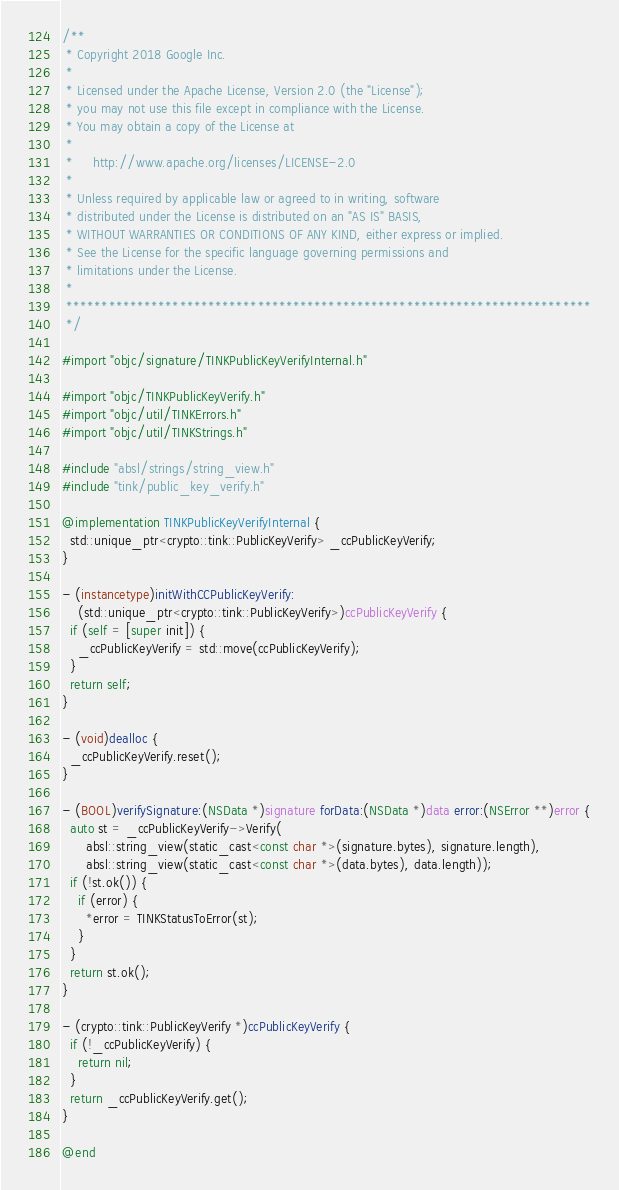Convert code to text. <code><loc_0><loc_0><loc_500><loc_500><_ObjectiveC_>/**
 * Copyright 2018 Google Inc.
 *
 * Licensed under the Apache License, Version 2.0 (the "License");
 * you may not use this file except in compliance with the License.
 * You may obtain a copy of the License at
 *
 *     http://www.apache.org/licenses/LICENSE-2.0
 *
 * Unless required by applicable law or agreed to in writing, software
 * distributed under the License is distributed on an "AS IS" BASIS,
 * WITHOUT WARRANTIES OR CONDITIONS OF ANY KIND, either express or implied.
 * See the License for the specific language governing permissions and
 * limitations under the License.
 *
 **************************************************************************
 */

#import "objc/signature/TINKPublicKeyVerifyInternal.h"

#import "objc/TINKPublicKeyVerify.h"
#import "objc/util/TINKErrors.h"
#import "objc/util/TINKStrings.h"

#include "absl/strings/string_view.h"
#include "tink/public_key_verify.h"

@implementation TINKPublicKeyVerifyInternal {
  std::unique_ptr<crypto::tink::PublicKeyVerify> _ccPublicKeyVerify;
}

- (instancetype)initWithCCPublicKeyVerify:
    (std::unique_ptr<crypto::tink::PublicKeyVerify>)ccPublicKeyVerify {
  if (self = [super init]) {
    _ccPublicKeyVerify = std::move(ccPublicKeyVerify);
  }
  return self;
}

- (void)dealloc {
  _ccPublicKeyVerify.reset();
}

- (BOOL)verifySignature:(NSData *)signature forData:(NSData *)data error:(NSError **)error {
  auto st = _ccPublicKeyVerify->Verify(
      absl::string_view(static_cast<const char *>(signature.bytes), signature.length),
      absl::string_view(static_cast<const char *>(data.bytes), data.length));
  if (!st.ok()) {
    if (error) {
      *error = TINKStatusToError(st);
    }
  }
  return st.ok();
}

- (crypto::tink::PublicKeyVerify *)ccPublicKeyVerify {
  if (!_ccPublicKeyVerify) {
    return nil;
  }
  return _ccPublicKeyVerify.get();
}

@end
</code> 